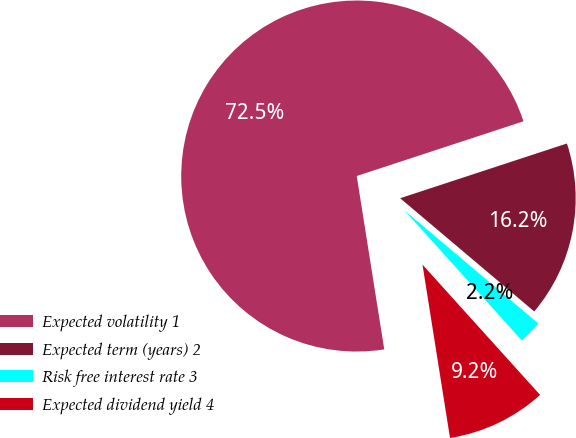Convert chart to OTSL. <chart><loc_0><loc_0><loc_500><loc_500><pie_chart><fcel>Expected volatility 1<fcel>Expected term (years) 2<fcel>Risk free interest rate 3<fcel>Expected dividend yield 4<nl><fcel>72.46%<fcel>16.21%<fcel>2.15%<fcel>9.18%<nl></chart> 